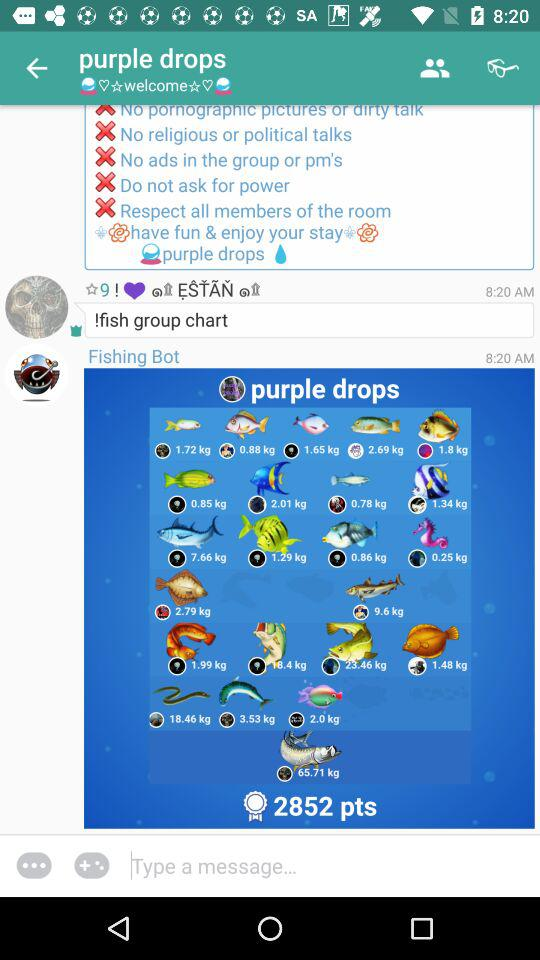How many more points does Fishing Bot have than the user with the green container with a lid?
Answer the question using a single word or phrase. 2852 